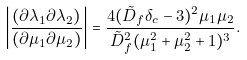Convert formula to latex. <formula><loc_0><loc_0><loc_500><loc_500>\left | \frac { ( \partial \lambda _ { 1 } \partial \lambda _ { 2 } ) } { ( \partial \mu _ { 1 } \partial \mu _ { 2 } ) } \right | = \frac { 4 ( \tilde { D } _ { f } \delta _ { c } - 3 ) ^ { 2 } \mu _ { 1 } \mu _ { 2 } } { \tilde { D } _ { f } ^ { 2 } ( \mu ^ { 2 } _ { 1 } + \mu ^ { 2 } _ { 2 } + 1 ) ^ { 3 } } .</formula> 